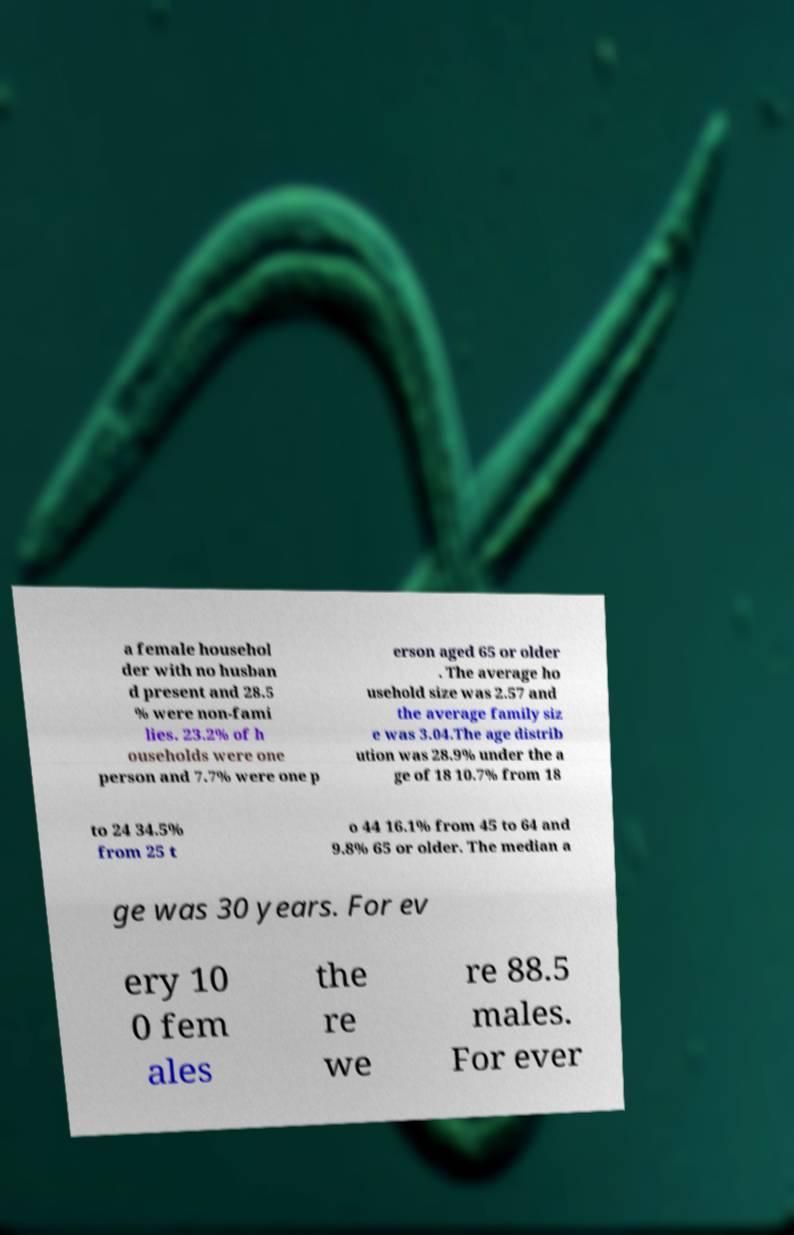Can you read and provide the text displayed in the image?This photo seems to have some interesting text. Can you extract and type it out for me? a female househol der with no husban d present and 28.5 % were non-fami lies. 23.2% of h ouseholds were one person and 7.7% were one p erson aged 65 or older . The average ho usehold size was 2.57 and the average family siz e was 3.04.The age distrib ution was 28.9% under the a ge of 18 10.7% from 18 to 24 34.5% from 25 t o 44 16.1% from 45 to 64 and 9.8% 65 or older. The median a ge was 30 years. For ev ery 10 0 fem ales the re we re 88.5 males. For ever 